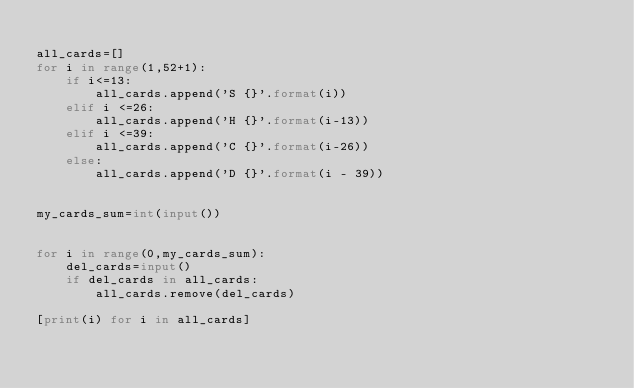<code> <loc_0><loc_0><loc_500><loc_500><_Python_>
all_cards=[]
for i in range(1,52+1):
    if i<=13:
        all_cards.append('S {}'.format(i))
    elif i <=26:
        all_cards.append('H {}'.format(i-13))
    elif i <=39:
        all_cards.append('C {}'.format(i-26))
    else:
        all_cards.append('D {}'.format(i - 39))


my_cards_sum=int(input())


for i in range(0,my_cards_sum):
    del_cards=input()
    if del_cards in all_cards:
        all_cards.remove(del_cards)

[print(i) for i in all_cards]
</code> 